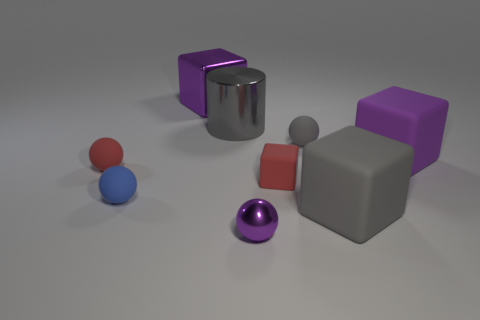Subtract all small red balls. How many balls are left? 3 Add 1 tiny purple rubber things. How many objects exist? 10 Subtract 1 cylinders. How many cylinders are left? 0 Subtract all gray cubes. How many cubes are left? 3 Subtract all cubes. How many objects are left? 5 Subtract all gray cylinders. How many cyan balls are left? 0 Subtract all large purple rubber blocks. Subtract all metal blocks. How many objects are left? 7 Add 6 purple matte objects. How many purple matte objects are left? 7 Add 2 big gray matte cubes. How many big gray matte cubes exist? 3 Subtract 0 brown cubes. How many objects are left? 9 